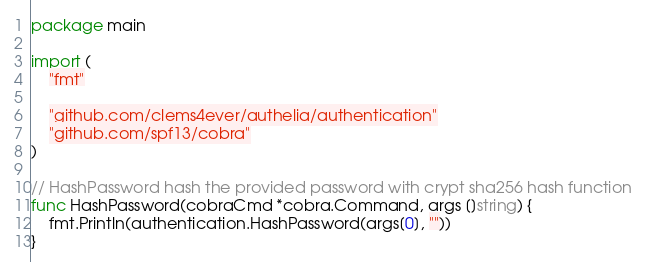<code> <loc_0><loc_0><loc_500><loc_500><_Go_>package main

import (
	"fmt"

	"github.com/clems4ever/authelia/authentication"
	"github.com/spf13/cobra"
)

// HashPassword hash the provided password with crypt sha256 hash function
func HashPassword(cobraCmd *cobra.Command, args []string) {
	fmt.Println(authentication.HashPassword(args[0], ""))
}
</code> 